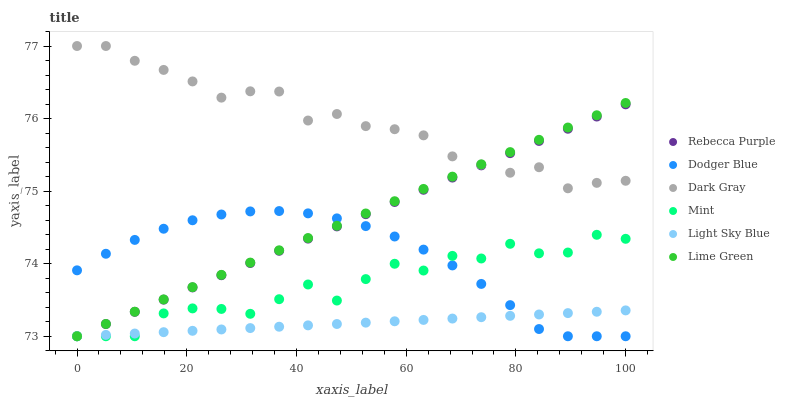Does Light Sky Blue have the minimum area under the curve?
Answer yes or no. Yes. Does Dark Gray have the maximum area under the curve?
Answer yes or no. Yes. Does Dark Gray have the minimum area under the curve?
Answer yes or no. No. Does Light Sky Blue have the maximum area under the curve?
Answer yes or no. No. Is Rebecca Purple the smoothest?
Answer yes or no. Yes. Is Mint the roughest?
Answer yes or no. Yes. Is Dark Gray the smoothest?
Answer yes or no. No. Is Dark Gray the roughest?
Answer yes or no. No. Does Lime Green have the lowest value?
Answer yes or no. Yes. Does Dark Gray have the lowest value?
Answer yes or no. No. Does Dark Gray have the highest value?
Answer yes or no. Yes. Does Light Sky Blue have the highest value?
Answer yes or no. No. Is Dodger Blue less than Dark Gray?
Answer yes or no. Yes. Is Dark Gray greater than Light Sky Blue?
Answer yes or no. Yes. Does Lime Green intersect Light Sky Blue?
Answer yes or no. Yes. Is Lime Green less than Light Sky Blue?
Answer yes or no. No. Is Lime Green greater than Light Sky Blue?
Answer yes or no. No. Does Dodger Blue intersect Dark Gray?
Answer yes or no. No. 